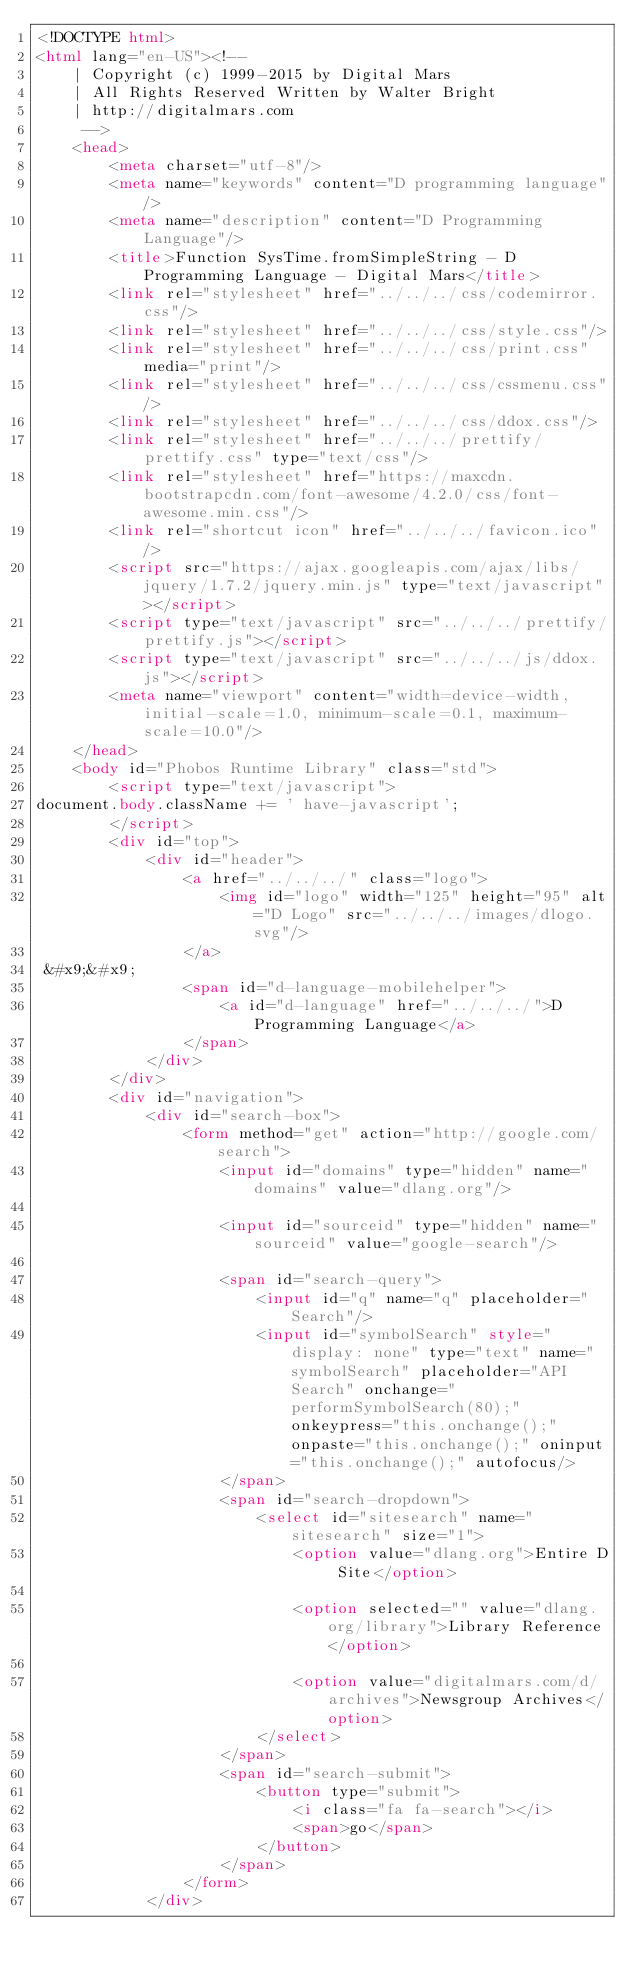Convert code to text. <code><loc_0><loc_0><loc_500><loc_500><_HTML_><!DOCTYPE html>
<html lang="en-US"><!-- 
    | Copyright (c) 1999-2015 by Digital Mars
    | All Rights Reserved Written by Walter Bright
    | http://digitalmars.com
	 -->
	<head>
		<meta charset="utf-8"/>
		<meta name="keywords" content="D programming language"/>
		<meta name="description" content="D Programming Language"/>
		<title>Function SysTime.fromSimpleString - D Programming Language - Digital Mars</title>
		<link rel="stylesheet" href="../../../css/codemirror.css"/>
		<link rel="stylesheet" href="../../../css/style.css"/>
		<link rel="stylesheet" href="../../../css/print.css" media="print"/>
		<link rel="stylesheet" href="../../../css/cssmenu.css"/>
		<link rel="stylesheet" href="../../../css/ddox.css"/>
		<link rel="stylesheet" href="../../../prettify/prettify.css" type="text/css"/>
		<link rel="stylesheet" href="https://maxcdn.bootstrapcdn.com/font-awesome/4.2.0/css/font-awesome.min.css"/>
		<link rel="shortcut icon" href="../../../favicon.ico"/>
		<script src="https://ajax.googleapis.com/ajax/libs/jquery/1.7.2/jquery.min.js" type="text/javascript"></script>
		<script type="text/javascript" src="../../../prettify/prettify.js"></script>
		<script type="text/javascript" src="../../../js/ddox.js"></script>
		<meta name="viewport" content="width=device-width, initial-scale=1.0, minimum-scale=0.1, maximum-scale=10.0"/>
	</head>
	<body id="Phobos Runtime Library" class="std">
		<script type="text/javascript">
document.body.className += ' have-javascript';
		</script>
		<div id="top">
			<div id="header">
				<a href="../../../" class="logo">
					<img id="logo" width="125" height="95" alt="D Logo" src="../../../images/dlogo.svg"/>
				</a>
 &#x9;&#x9;
				<span id="d-language-mobilehelper">
					<a id="d-language" href="../../../">D Programming Language</a>
				</span>
			</div>
		</div>
		<div id="navigation">
			<div id="search-box">
				<form method="get" action="http://google.com/search">
					<input id="domains" type="hidden" name="domains" value="dlang.org"/>
             
					<input id="sourceid" type="hidden" name="sourceid" value="google-search"/>
             
					<span id="search-query">
						<input id="q" name="q" placeholder="Search"/>
						<input id="symbolSearch" style="display: none" type="text" name="symbolSearch" placeholder="API Search" onchange="performSymbolSearch(80);" onkeypress="this.onchange();" onpaste="this.onchange();" oninput="this.onchange();" autofocus/>
					</span>
					<span id="search-dropdown">
						<select id="sitesearch" name="sitesearch" size="1">
							<option value="dlang.org">Entire D Site</option>
                     
							<option selected="" value="dlang.org/library">Library Reference</option>
                     
							<option value="digitalmars.com/d/archives">Newsgroup Archives</option>
						</select>
					</span>
					<span id="search-submit">
						<button type="submit">
							<i class="fa fa-search"></i>
							<span>go</span>
						</button>
					</span>
				</form>
			</div></code> 